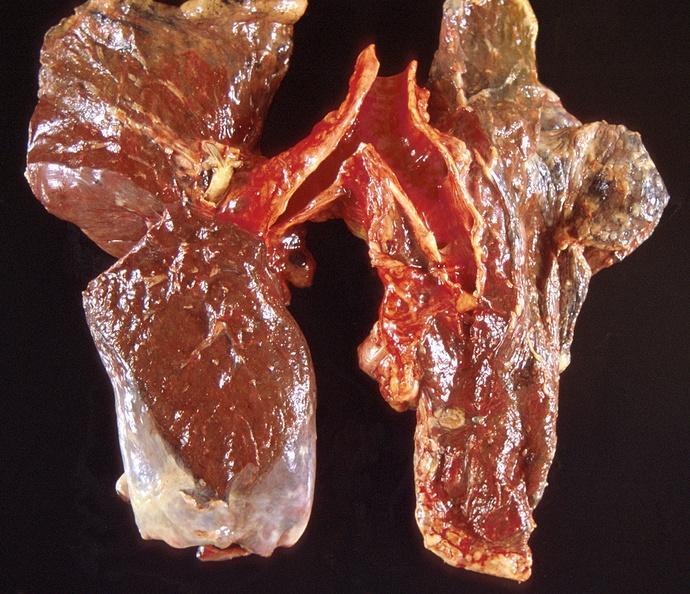s intraductal papillomatosis present?
Answer the question using a single word or phrase. No 